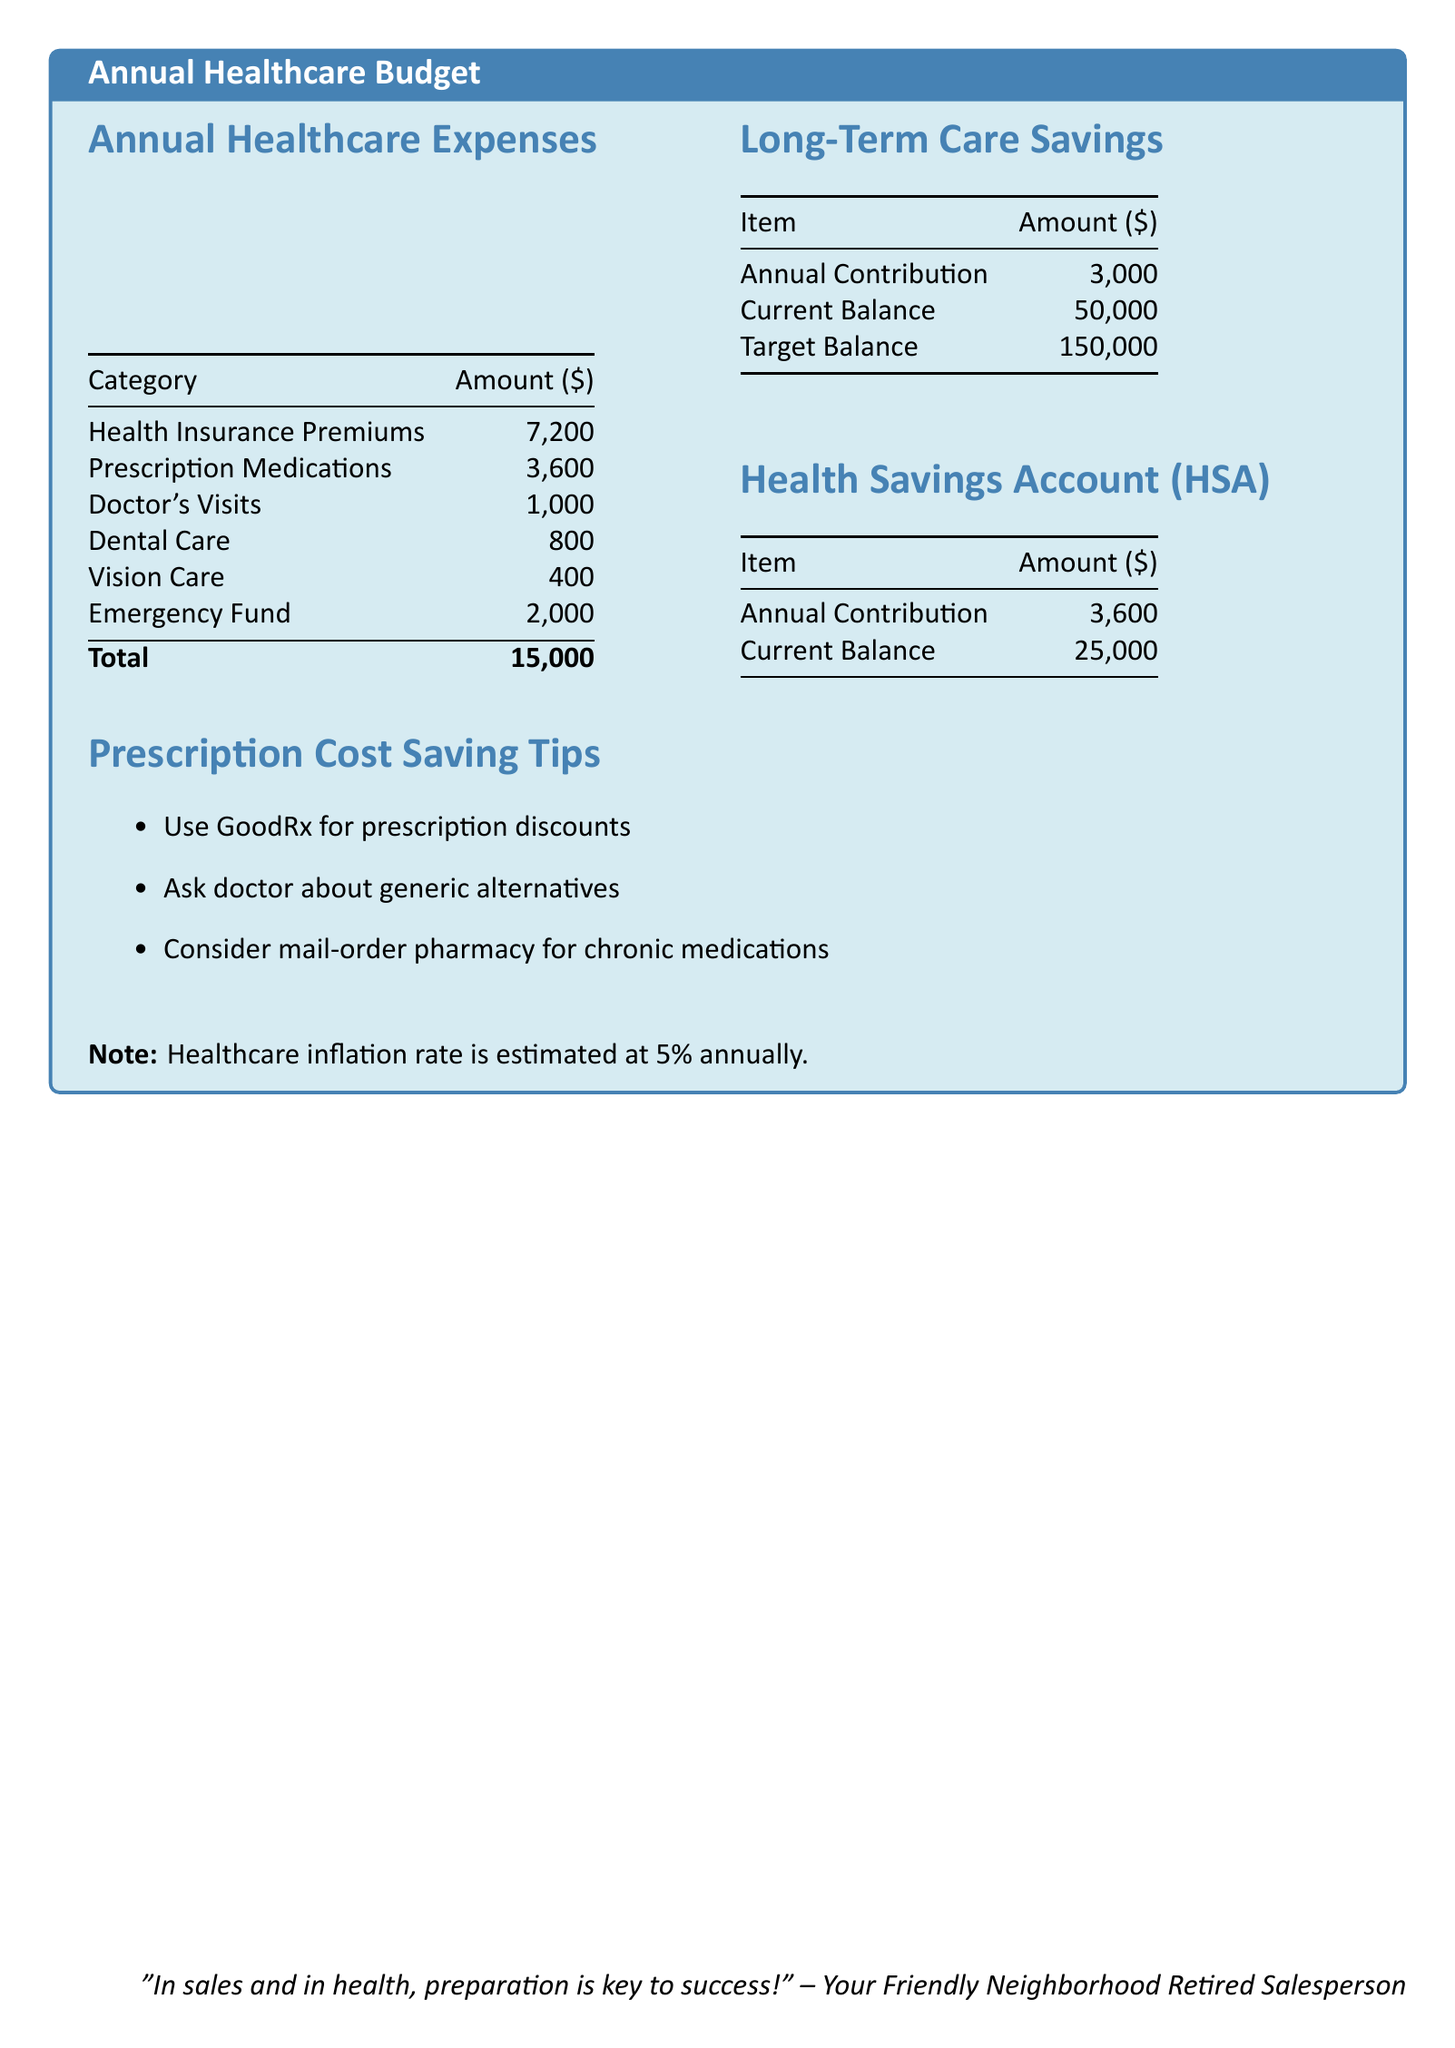what is the total annual healthcare expense? The total annual healthcare expense is listed at the bottom of the healthcare expenses section, which sums all individual expenses to $15,000.
Answer: $15,000 how much is allocated for prescription medications? The prescription medications cost is explicitly mentioned in the healthcare expenses section, shown as $3,600.
Answer: $3,600 what is the current balance of the long-term care savings? The current balance of the long-term care savings is detailed in the long-term care savings table as $50,000.
Answer: $50,000 what is the annual contribution to the Health Savings Account? The annual contribution for the Health Savings Account is specified in the HSA table as $3,600.
Answer: $3,600 what percentage is the healthcare inflation rate? The healthcare inflation rate is noted at the bottom of the document, which is estimated at 5% annually.
Answer: 5% how much is set aside for the emergency fund? The amount designated for the emergency fund is noted in the healthcare expenses section, which is $2,000.
Answer: $2,000 what is the target balance for long-term care savings? The target balance for long-term care savings is indicated in the long-term care savings table as $150,000.
Answer: $150,000 what are two ways to save on prescription costs listed in the document? The document provides tips for prescription cost savings, such as using GoodRx and asking the doctor about generic alternatives.
Answer: GoodRx, generic alternatives 